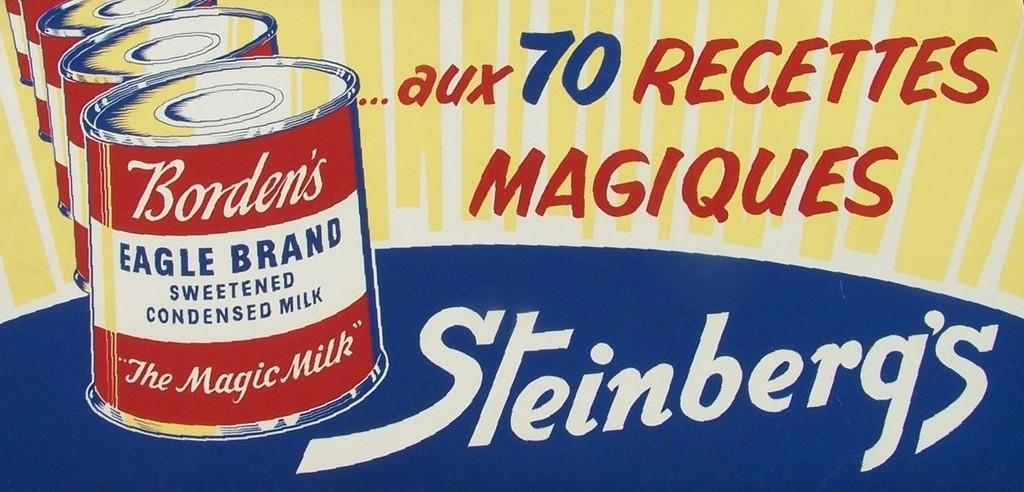Provide a one-sentence caption for the provided image. some cans that say steinberg's on it with a cartoon image. 